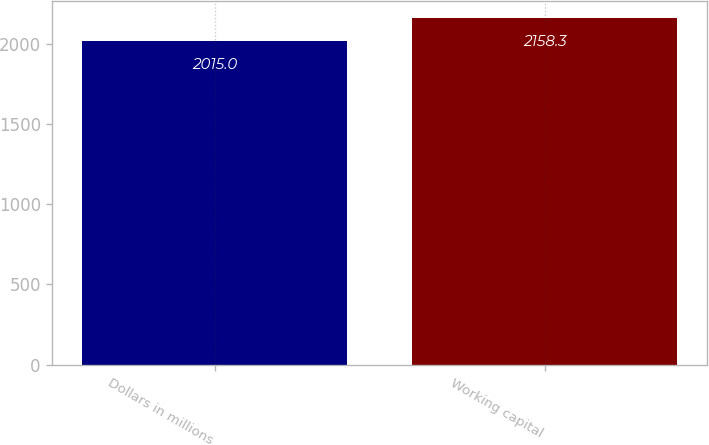Convert chart to OTSL. <chart><loc_0><loc_0><loc_500><loc_500><bar_chart><fcel>Dollars in millions<fcel>Working capital<nl><fcel>2015<fcel>2158.3<nl></chart> 